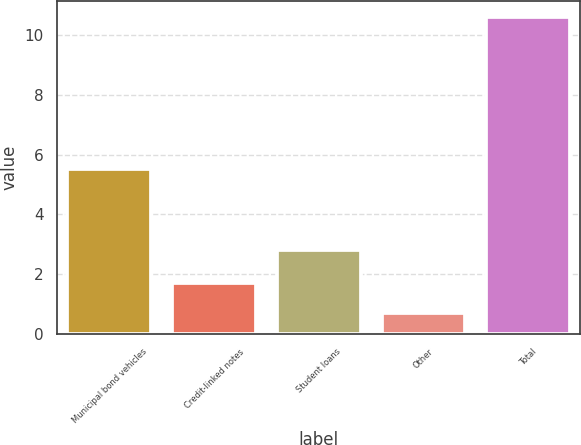<chart> <loc_0><loc_0><loc_500><loc_500><bar_chart><fcel>Municipal bond vehicles<fcel>Credit-linked notes<fcel>Student loans<fcel>Other<fcel>Total<nl><fcel>5.5<fcel>1.69<fcel>2.8<fcel>0.7<fcel>10.6<nl></chart> 